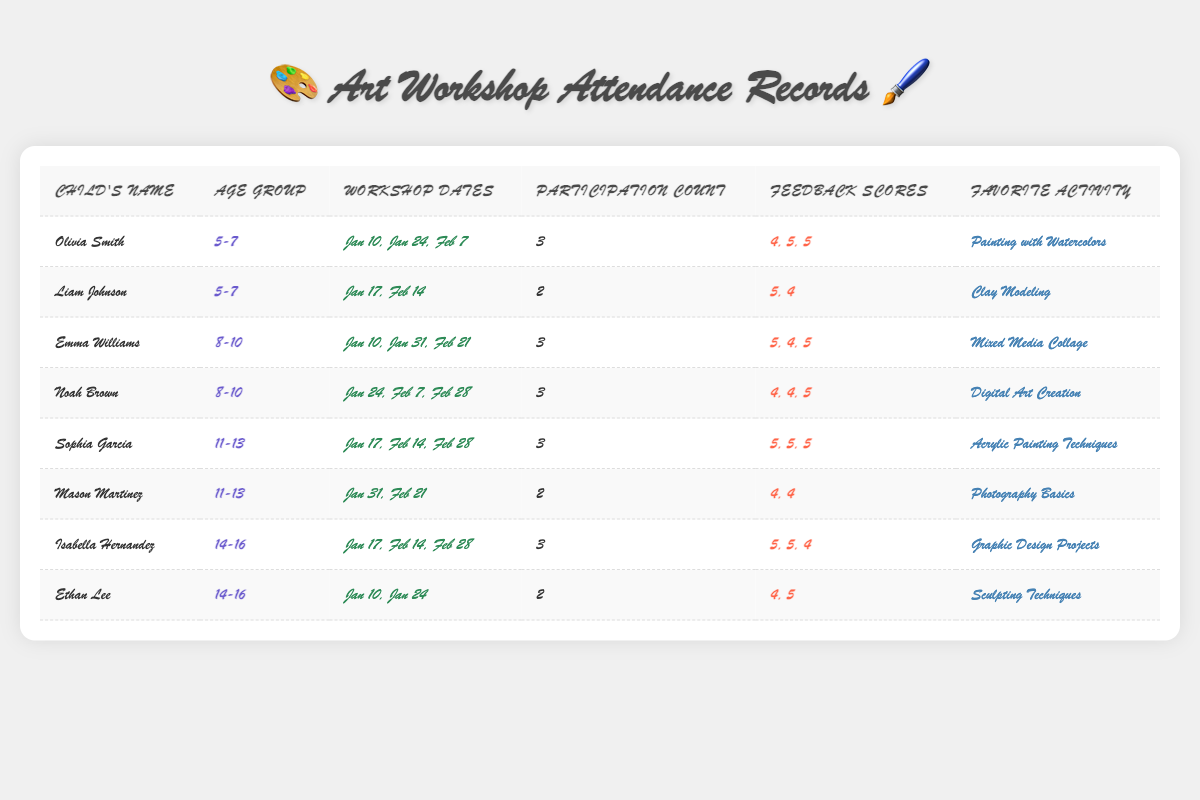What is the favorite activity of Noah Brown? Referring to the table, Noah Brown's favorite activity is listed under the "Favorite Activity" column. It reads "Digital Art Creation."
Answer: Digital Art Creation How many workshops did Olivia Smith attend? Olivia Smith's total workshop participation count is indicated in the "Participation Count" column, which shows the value as 3.
Answer: 3 What is the average feedback score for children in the age group 5-7? The feedback scores for the 5-7 age group are 4, 5, 5 (Olivia Smith) and 5, 4 (Liam Johnson). Adding these gives 4 + 5 + 5 + 5 + 4 = 23. There are 5 scores, so the average is 23/5 = 4.6.
Answer: 4.6 Did Sophia Garcia attend all workshops listed for her age group? Sophia Garcia attended 3 workshops on the dates provided; thus, she participated in all the workshops listed.
Answer: Yes Which age group has the highest total workshop attendance? The attendance counts are 3 (Olivia), 2 (Liam) for 5-7; 3 (Emma), 3 (Noah) for 8-10; 3 (Sophia), 2 (Mason) for 11-13; 3 (Isabella), 2 (Ethan) for 14-16. Calculating gives 5-7 (5), 8-10 (6), 11-13 (5), and 14-16 (5). The highest is 8-10 with 6.
Answer: 8-10 How many workshops did Isabella Hernandez attend in total? Under the "Participation Count" for Isabella Hernandez, it shows the number 3, indicating she attended 3 workshops.
Answer: 3 What was Mason Martinez's average feedback score? Mason's feedback scores are 4 and 4. Adding these gives 4 + 4 = 8. There are 2 scores, so the average is 8/2 = 4.
Answer: 4 Which child reported the highest feedback score across all workshops? Sophia Garcia's feedback scores are 5, 5, and 5, which is the highest amongst all. No other child has all perfect scores.
Answer: Sophia Garcia Is there a child in the 14-16 age group who participated in fewer than 3 workshops? Yes, Ethan Lee participated in only 2 workshops, which is noted in the "Participation Count."
Answer: Yes Which activity was the favorite of the child with the highest participation count in their age group? The child with the highest participation count in the 5-7 age group is Olivia Smith with 3 participations and her favorite activity is "Painting with Watercolors."
Answer: Painting with Watercolors How many feedback scores did Noah Brown receive, and what was the lowest? Noah Brown received 3 feedback scores: 4, 4, and 5. The lowest among these is 4.
Answer: 4 